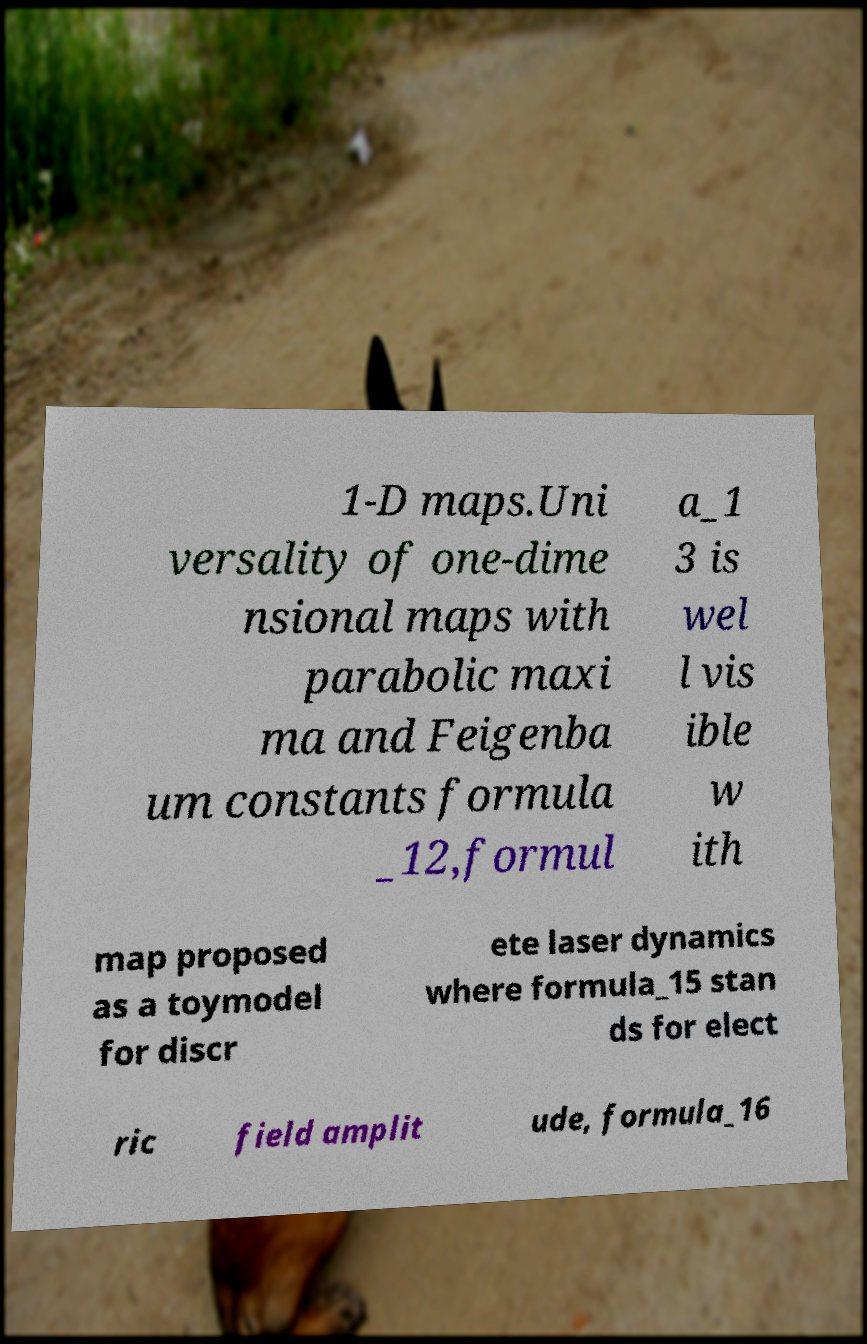Please read and relay the text visible in this image. What does it say? 1-D maps.Uni versality of one-dime nsional maps with parabolic maxi ma and Feigenba um constants formula _12,formul a_1 3 is wel l vis ible w ith map proposed as a toymodel for discr ete laser dynamics where formula_15 stan ds for elect ric field amplit ude, formula_16 